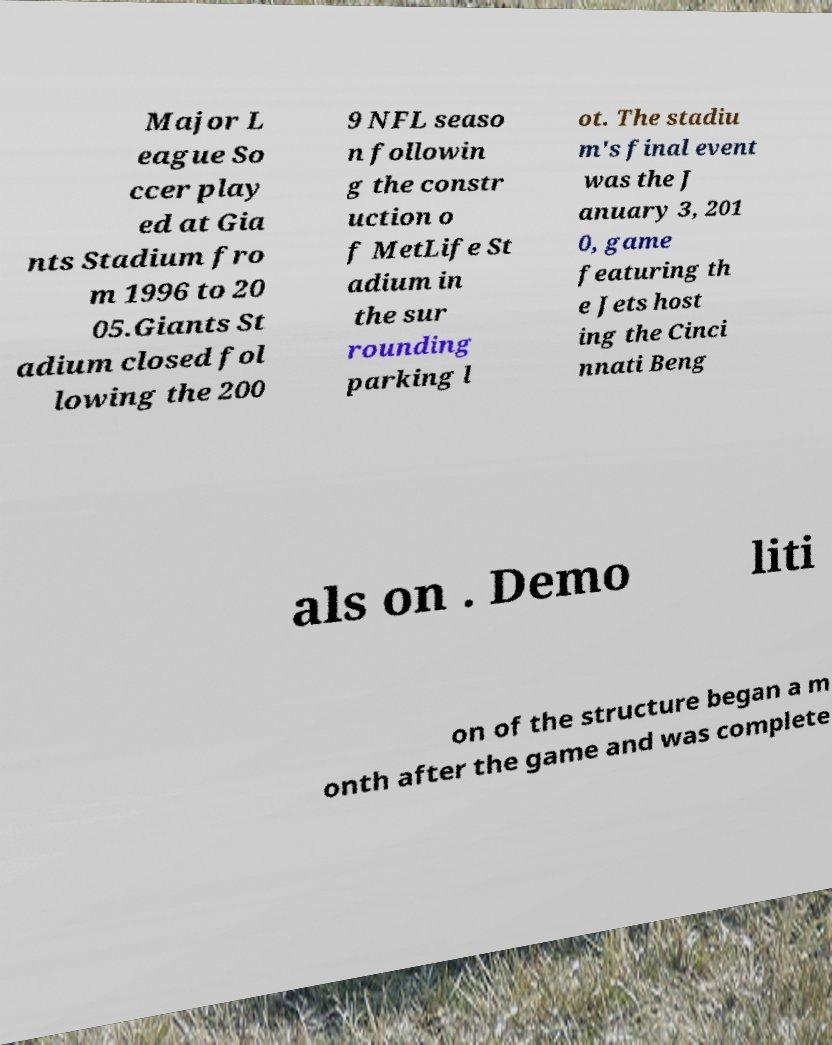Could you extract and type out the text from this image? Major L eague So ccer play ed at Gia nts Stadium fro m 1996 to 20 05.Giants St adium closed fol lowing the 200 9 NFL seaso n followin g the constr uction o f MetLife St adium in the sur rounding parking l ot. The stadiu m's final event was the J anuary 3, 201 0, game featuring th e Jets host ing the Cinci nnati Beng als on . Demo liti on of the structure began a m onth after the game and was complete 